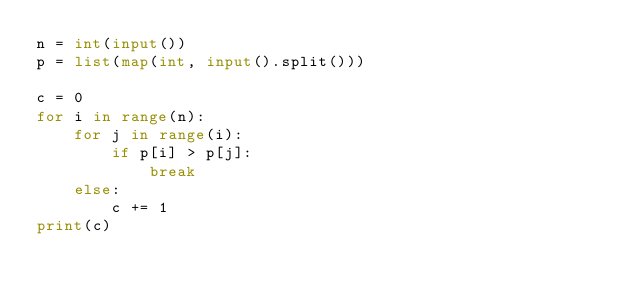<code> <loc_0><loc_0><loc_500><loc_500><_Python_>n = int(input())
p = list(map(int, input().split()))

c = 0
for i in range(n):
    for j in range(i):
        if p[i] > p[j]:
            break
    else:
        c += 1
print(c)</code> 